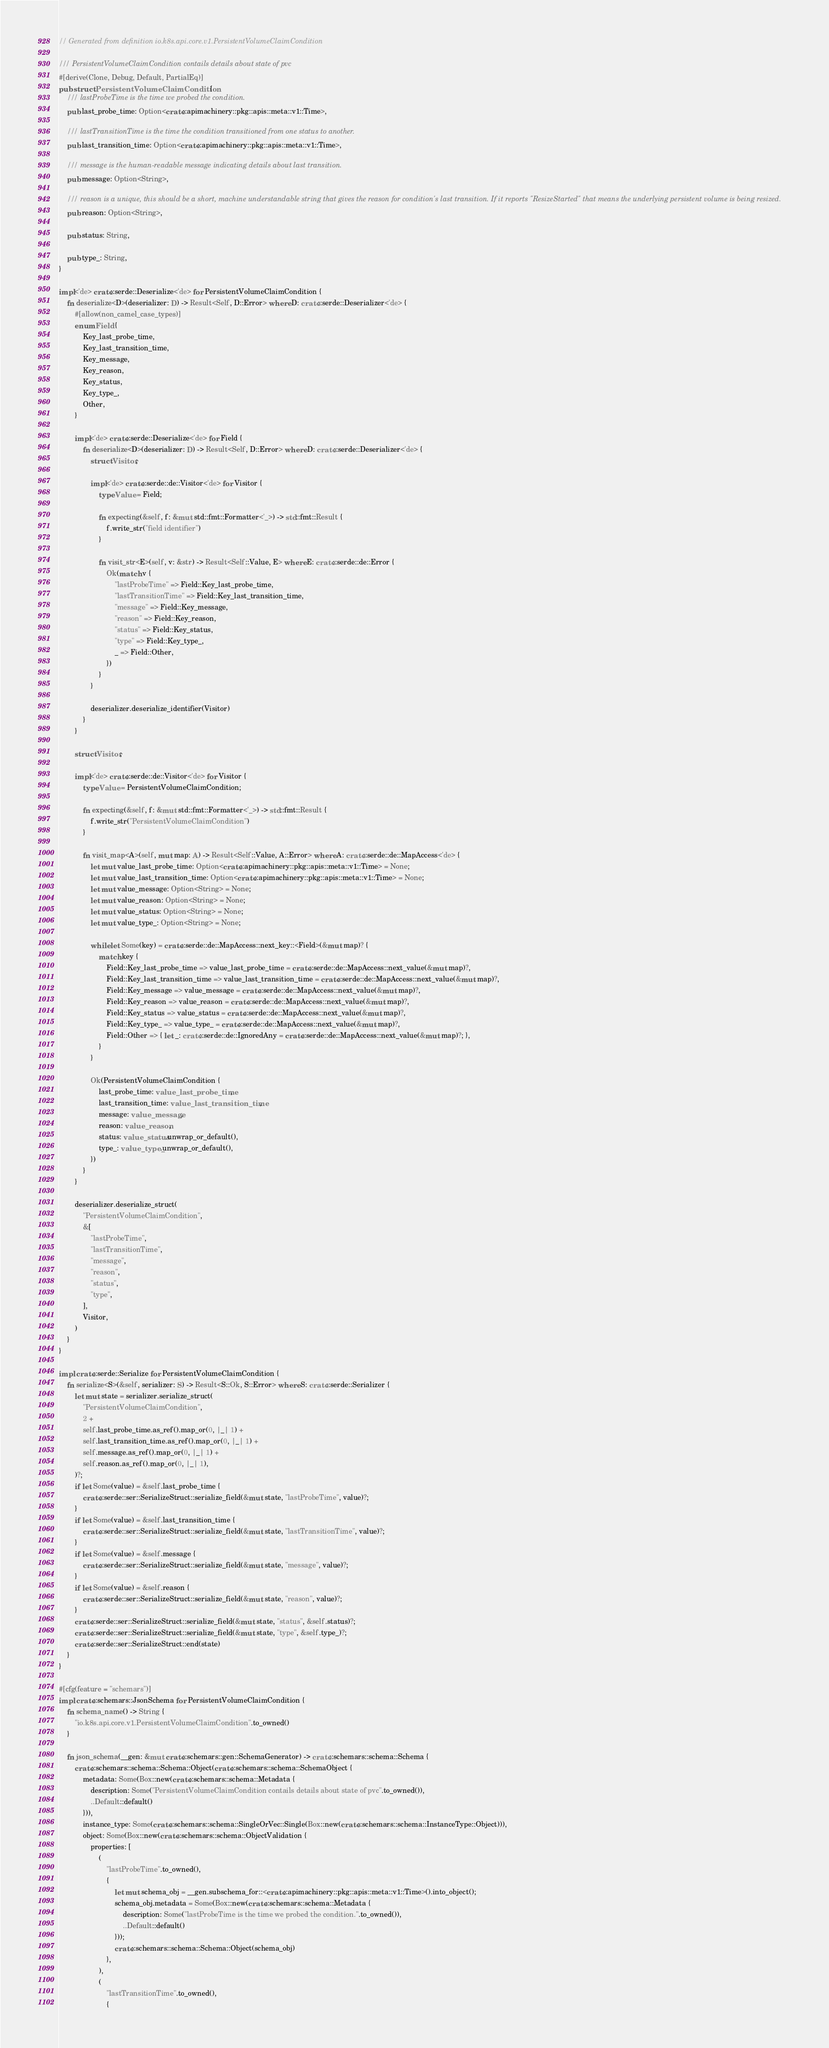<code> <loc_0><loc_0><loc_500><loc_500><_Rust_>// Generated from definition io.k8s.api.core.v1.PersistentVolumeClaimCondition

/// PersistentVolumeClaimCondition contails details about state of pvc
#[derive(Clone, Debug, Default, PartialEq)]
pub struct PersistentVolumeClaimCondition {
    /// lastProbeTime is the time we probed the condition.
    pub last_probe_time: Option<crate::apimachinery::pkg::apis::meta::v1::Time>,

    /// lastTransitionTime is the time the condition transitioned from one status to another.
    pub last_transition_time: Option<crate::apimachinery::pkg::apis::meta::v1::Time>,

    /// message is the human-readable message indicating details about last transition.
    pub message: Option<String>,

    /// reason is a unique, this should be a short, machine understandable string that gives the reason for condition's last transition. If it reports "ResizeStarted" that means the underlying persistent volume is being resized.
    pub reason: Option<String>,

    pub status: String,

    pub type_: String,
}

impl<'de> crate::serde::Deserialize<'de> for PersistentVolumeClaimCondition {
    fn deserialize<D>(deserializer: D) -> Result<Self, D::Error> where D: crate::serde::Deserializer<'de> {
        #[allow(non_camel_case_types)]
        enum Field {
            Key_last_probe_time,
            Key_last_transition_time,
            Key_message,
            Key_reason,
            Key_status,
            Key_type_,
            Other,
        }

        impl<'de> crate::serde::Deserialize<'de> for Field {
            fn deserialize<D>(deserializer: D) -> Result<Self, D::Error> where D: crate::serde::Deserializer<'de> {
                struct Visitor;

                impl<'de> crate::serde::de::Visitor<'de> for Visitor {
                    type Value = Field;

                    fn expecting(&self, f: &mut std::fmt::Formatter<'_>) -> std::fmt::Result {
                        f.write_str("field identifier")
                    }

                    fn visit_str<E>(self, v: &str) -> Result<Self::Value, E> where E: crate::serde::de::Error {
                        Ok(match v {
                            "lastProbeTime" => Field::Key_last_probe_time,
                            "lastTransitionTime" => Field::Key_last_transition_time,
                            "message" => Field::Key_message,
                            "reason" => Field::Key_reason,
                            "status" => Field::Key_status,
                            "type" => Field::Key_type_,
                            _ => Field::Other,
                        })
                    }
                }

                deserializer.deserialize_identifier(Visitor)
            }
        }

        struct Visitor;

        impl<'de> crate::serde::de::Visitor<'de> for Visitor {
            type Value = PersistentVolumeClaimCondition;

            fn expecting(&self, f: &mut std::fmt::Formatter<'_>) -> std::fmt::Result {
                f.write_str("PersistentVolumeClaimCondition")
            }

            fn visit_map<A>(self, mut map: A) -> Result<Self::Value, A::Error> where A: crate::serde::de::MapAccess<'de> {
                let mut value_last_probe_time: Option<crate::apimachinery::pkg::apis::meta::v1::Time> = None;
                let mut value_last_transition_time: Option<crate::apimachinery::pkg::apis::meta::v1::Time> = None;
                let mut value_message: Option<String> = None;
                let mut value_reason: Option<String> = None;
                let mut value_status: Option<String> = None;
                let mut value_type_: Option<String> = None;

                while let Some(key) = crate::serde::de::MapAccess::next_key::<Field>(&mut map)? {
                    match key {
                        Field::Key_last_probe_time => value_last_probe_time = crate::serde::de::MapAccess::next_value(&mut map)?,
                        Field::Key_last_transition_time => value_last_transition_time = crate::serde::de::MapAccess::next_value(&mut map)?,
                        Field::Key_message => value_message = crate::serde::de::MapAccess::next_value(&mut map)?,
                        Field::Key_reason => value_reason = crate::serde::de::MapAccess::next_value(&mut map)?,
                        Field::Key_status => value_status = crate::serde::de::MapAccess::next_value(&mut map)?,
                        Field::Key_type_ => value_type_ = crate::serde::de::MapAccess::next_value(&mut map)?,
                        Field::Other => { let _: crate::serde::de::IgnoredAny = crate::serde::de::MapAccess::next_value(&mut map)?; },
                    }
                }

                Ok(PersistentVolumeClaimCondition {
                    last_probe_time: value_last_probe_time,
                    last_transition_time: value_last_transition_time,
                    message: value_message,
                    reason: value_reason,
                    status: value_status.unwrap_or_default(),
                    type_: value_type_.unwrap_or_default(),
                })
            }
        }

        deserializer.deserialize_struct(
            "PersistentVolumeClaimCondition",
            &[
                "lastProbeTime",
                "lastTransitionTime",
                "message",
                "reason",
                "status",
                "type",
            ],
            Visitor,
        )
    }
}

impl crate::serde::Serialize for PersistentVolumeClaimCondition {
    fn serialize<S>(&self, serializer: S) -> Result<S::Ok, S::Error> where S: crate::serde::Serializer {
        let mut state = serializer.serialize_struct(
            "PersistentVolumeClaimCondition",
            2 +
            self.last_probe_time.as_ref().map_or(0, |_| 1) +
            self.last_transition_time.as_ref().map_or(0, |_| 1) +
            self.message.as_ref().map_or(0, |_| 1) +
            self.reason.as_ref().map_or(0, |_| 1),
        )?;
        if let Some(value) = &self.last_probe_time {
            crate::serde::ser::SerializeStruct::serialize_field(&mut state, "lastProbeTime", value)?;
        }
        if let Some(value) = &self.last_transition_time {
            crate::serde::ser::SerializeStruct::serialize_field(&mut state, "lastTransitionTime", value)?;
        }
        if let Some(value) = &self.message {
            crate::serde::ser::SerializeStruct::serialize_field(&mut state, "message", value)?;
        }
        if let Some(value) = &self.reason {
            crate::serde::ser::SerializeStruct::serialize_field(&mut state, "reason", value)?;
        }
        crate::serde::ser::SerializeStruct::serialize_field(&mut state, "status", &self.status)?;
        crate::serde::ser::SerializeStruct::serialize_field(&mut state, "type", &self.type_)?;
        crate::serde::ser::SerializeStruct::end(state)
    }
}

#[cfg(feature = "schemars")]
impl crate::schemars::JsonSchema for PersistentVolumeClaimCondition {
    fn schema_name() -> String {
        "io.k8s.api.core.v1.PersistentVolumeClaimCondition".to_owned()
    }

    fn json_schema(__gen: &mut crate::schemars::gen::SchemaGenerator) -> crate::schemars::schema::Schema {
        crate::schemars::schema::Schema::Object(crate::schemars::schema::SchemaObject {
            metadata: Some(Box::new(crate::schemars::schema::Metadata {
                description: Some("PersistentVolumeClaimCondition contails details about state of pvc".to_owned()),
                ..Default::default()
            })),
            instance_type: Some(crate::schemars::schema::SingleOrVec::Single(Box::new(crate::schemars::schema::InstanceType::Object))),
            object: Some(Box::new(crate::schemars::schema::ObjectValidation {
                properties: [
                    (
                        "lastProbeTime".to_owned(),
                        {
                            let mut schema_obj = __gen.subschema_for::<crate::apimachinery::pkg::apis::meta::v1::Time>().into_object();
                            schema_obj.metadata = Some(Box::new(crate::schemars::schema::Metadata {
                                description: Some("lastProbeTime is the time we probed the condition.".to_owned()),
                                ..Default::default()
                            }));
                            crate::schemars::schema::Schema::Object(schema_obj)
                        },
                    ),
                    (
                        "lastTransitionTime".to_owned(),
                        {</code> 